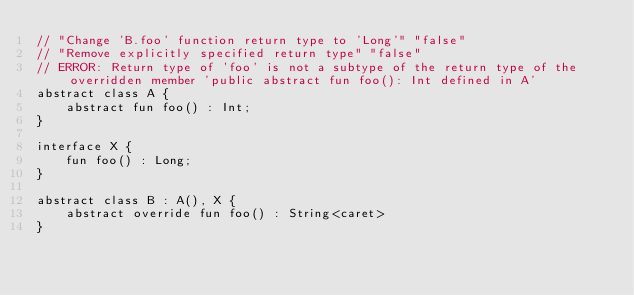<code> <loc_0><loc_0><loc_500><loc_500><_Kotlin_>// "Change 'B.foo' function return type to 'Long'" "false"
// "Remove explicitly specified return type" "false"
// ERROR: Return type of 'foo' is not a subtype of the return type of the overridden member 'public abstract fun foo(): Int defined in A'
abstract class A {
    abstract fun foo() : Int;
}

interface X {
    fun foo() : Long;
}

abstract class B : A(), X {
    abstract override fun foo() : String<caret>
}
</code> 